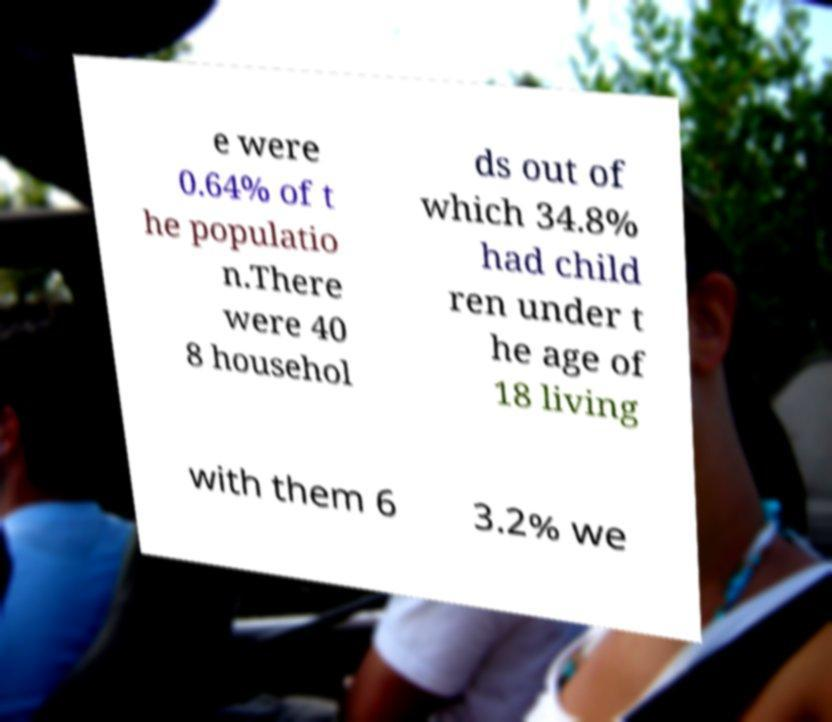Can you accurately transcribe the text from the provided image for me? e were 0.64% of t he populatio n.There were 40 8 househol ds out of which 34.8% had child ren under t he age of 18 living with them 6 3.2% we 